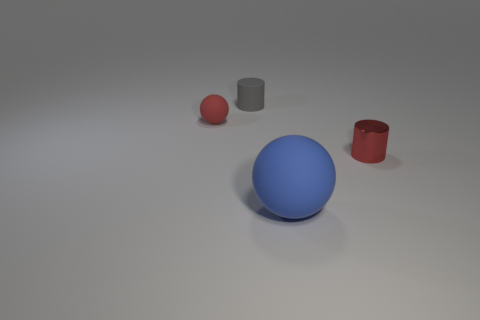Does the large matte object have the same shape as the tiny red shiny thing?
Provide a short and direct response. No. How many other objects are there of the same material as the tiny red sphere?
Make the answer very short. 2. How many other metallic things have the same shape as the small gray object?
Provide a succinct answer. 1. The thing that is both behind the big thing and in front of the red rubber thing is what color?
Keep it short and to the point. Red. What number of blue balls are there?
Provide a short and direct response. 1. Does the red rubber thing have the same size as the blue object?
Your answer should be very brief. No. Is there a small cylinder of the same color as the big matte object?
Give a very brief answer. No. There is a small red thing that is on the left side of the big rubber ball; does it have the same shape as the small red metallic object?
Keep it short and to the point. No. What number of red metallic objects have the same size as the red rubber thing?
Ensure brevity in your answer.  1. There is a tiny gray rubber cylinder that is behind the blue rubber object; what number of blue things are to the left of it?
Make the answer very short. 0. 